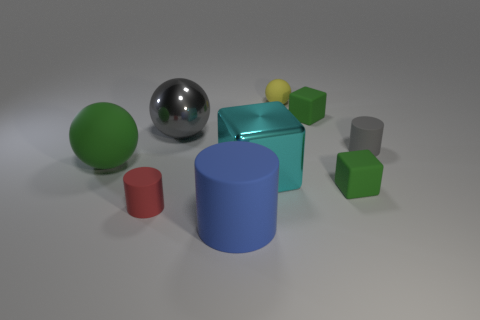What number of other things are made of the same material as the red cylinder?
Your response must be concise. 6. What shape is the tiny red thing that is made of the same material as the big green ball?
Make the answer very short. Cylinder. Are there any other things of the same color as the big matte sphere?
Offer a very short reply. Yes. What is the size of the matte object that is the same color as the large metallic ball?
Make the answer very short. Small. Is the number of rubber cubes that are behind the large green sphere greater than the number of small cyan rubber objects?
Provide a short and direct response. Yes. There is a large cyan metallic thing; is it the same shape as the tiny green rubber thing in front of the gray rubber thing?
Ensure brevity in your answer.  Yes. How many objects have the same size as the gray sphere?
Keep it short and to the point. 3. How many rubber cubes are to the left of the tiny green matte object to the right of the green cube that is behind the large cyan shiny thing?
Make the answer very short. 1. Are there the same number of large rubber objects on the left side of the big blue rubber cylinder and rubber cylinders on the left side of the small ball?
Your answer should be compact. No. What number of rubber objects are the same shape as the big cyan shiny thing?
Your answer should be compact. 2. 